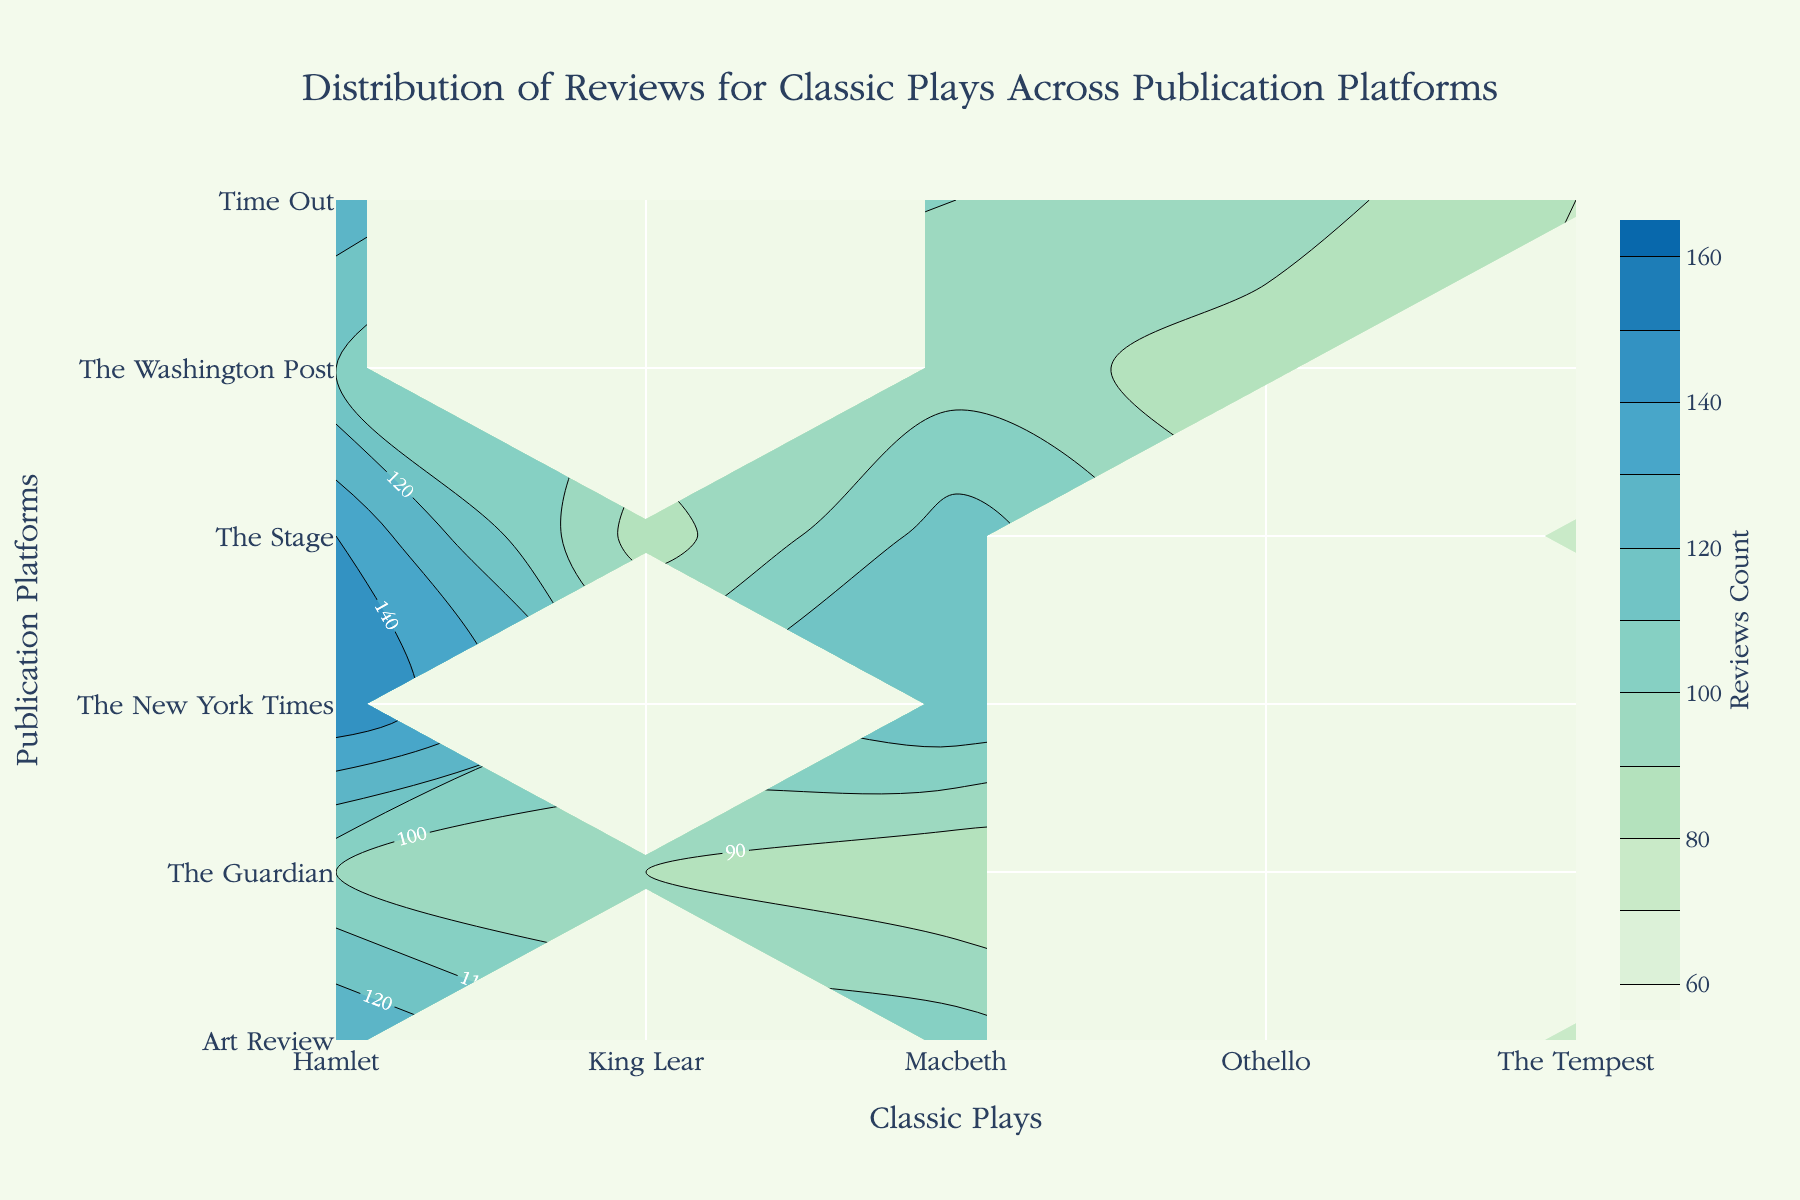What is the title of the figure? The title of the figure is prominently displayed at the top in larger font.
Answer: Distribution of Reviews for Classic Plays Across Publication Platforms Which publication platform has the highest reviews count for "Hamlet"? To determine this, look at the contour lines and labels corresponding to "Hamlet" on the horizontal axis, then find the highest value on the vertical axis.
Answer: The New York Times How many classic plays does "The Guardian" review? Find "The Guardian" on the vertical axis and count the distinct classic plays labeled on the horizontal axis that align with it.
Answer: 3 What is the range of reviews count shown in the color bar? The color bar on the right side of the plot gives the range, starting from the lowest to the highest value.
Answer: 60 to 160 Which classic play has the lowest maximum reviews count across all publication platforms? Look at the maximum values for each classic play along the horizontal axis and identify the lowest among them.
Answer: The Tempest Which publication platform has reviewed both "Othello" and "The Tempest"? Locate "Othello" and "The Tempest" on the horizontal axis and find publication platforms that correspond to both plays.
Answer: Time Out Compare the reviews count for "Macbeth" between "The New York Times" and "The Stage". Which one has more reviews? Follow the contour lines for "Macbeth" from both "The New York Times" and "The Stage" and compare their review counts.
Answer: The New York Times What is the average number of reviews for all plays reviewed by "Art Review"? Combine the review numbers for all plays under "Art Review" and divide by the number of plays. Calculation: (130 + 105 + 75) / 3
Answer: 103.33 Which classic play is the most frequently reviewed across all publication platforms? Sum up reviews for each play across all publication platforms and identify the play with the highest total. Calculation: Hamlet (150+100+110+130+140+125), Macbeth (120+80+95+105+115+100), etc.
Answer: Hamlet Are there any classic plays reviewed by all five publication platforms? Check if any classic play appears in the contour plot labels for all five publication platforms.
Answer: Hamlet, Macbeth 